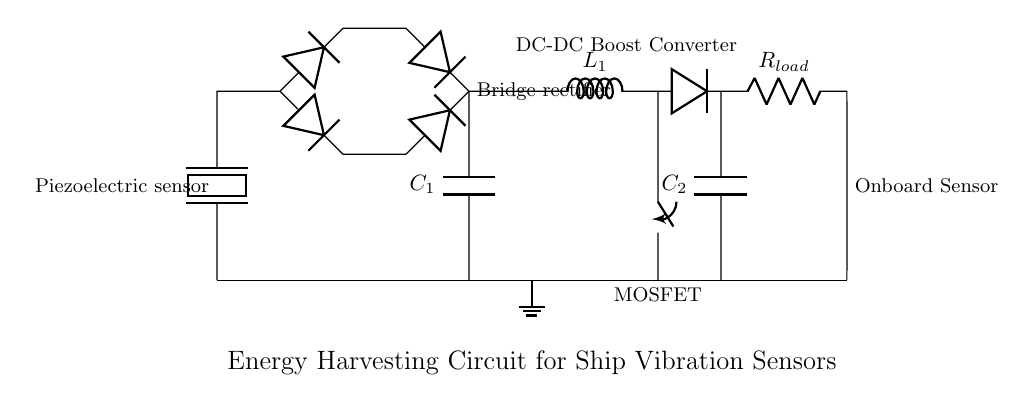What type of energy conversion is utilized by this circuit? The circuit utilizes mechanical to electrical energy conversion through the piezoelectric sensor, which generates an electrical charge when subjected to mechanical stress or vibrations.
Answer: mechanical to electrical energy What component is responsible for rectifying the AC signals generated by the piezoelectric sensor? The bridge rectifier, composed of four diodes, transforms the alternating current (AC) generated by the piezoelectric element into direct current (DC) for the subsequent stages in the circuit.
Answer: bridge rectifier What is the purpose of the smoothing capacitor in this circuit? The smoothing capacitor filters the rectified voltage, reducing fluctuations and providing a more stable DC output voltage to power the load. This helps ensure that the onboard sensor receives consistent voltage levels for proper operation.
Answer: smoothing capacitor How many diodes are used in the bridge rectifier? There are four diodes used in the bridge rectifier configuration, allowing for full-wave rectification of the AC signals generated by the piezoelectric sensor.
Answer: four diodes What does the load represent in this circuit? The load represents the onboard sensor that typically monitors environmental variables, such as temperature or vibration levels, and it draws power from the circuit to operate.
Answer: onboard sensor What component is used to boost the voltage in the circuit? The DC-DC boost converter is employed to increase the output voltage from the smoothing capacitor to a higher level required by the load. This component ensures that the onboard sensor receives sufficient voltage even at low energy input levels from the piezoelectric sensor.
Answer: DC-DC boost converter 